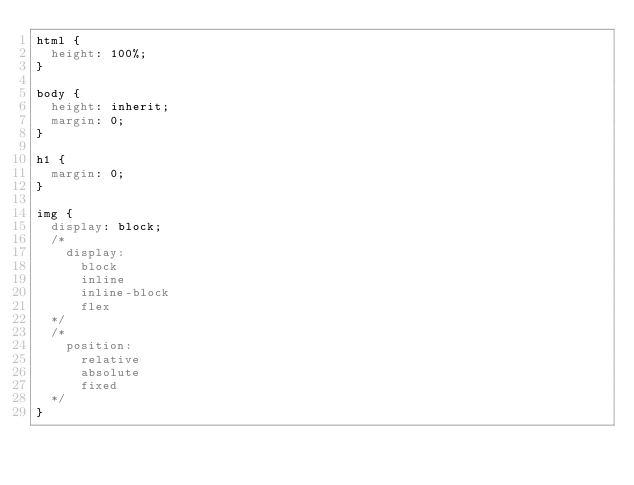Convert code to text. <code><loc_0><loc_0><loc_500><loc_500><_CSS_>html {
  height: 100%;
}

body {
  height: inherit;
  margin: 0;
}

h1 {
  margin: 0;
}

img {
  display: block;
  /* 
    display:
      block
      inline
      inline-block
      flex
  */
  /* 
    position:
      relative
      absolute
      fixed
  */
}</code> 